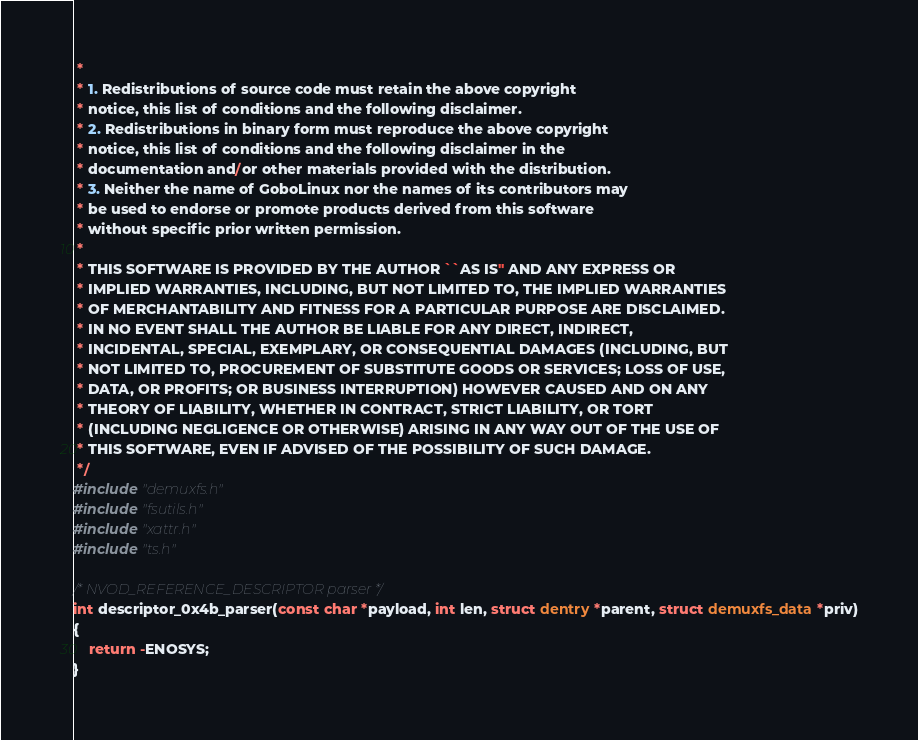<code> <loc_0><loc_0><loc_500><loc_500><_C_> * 
 * 1. Redistributions of source code must retain the above copyright
 * notice, this list of conditions and the following disclaimer.
 * 2. Redistributions in binary form must reproduce the above copyright
 * notice, this list of conditions and the following disclaimer in the
 * documentation and/or other materials provided with the distribution.
 * 3. Neither the name of GoboLinux nor the names of its contributors may
 * be used to endorse or promote products derived from this software
 * without specific prior written permission.
 * 
 * THIS SOFTWARE IS PROVIDED BY THE AUTHOR ``AS IS'' AND ANY EXPRESS OR
 * IMPLIED WARRANTIES, INCLUDING, BUT NOT LIMITED TO, THE IMPLIED WARRANTIES
 * OF MERCHANTABILITY AND FITNESS FOR A PARTICULAR PURPOSE ARE DISCLAIMED.
 * IN NO EVENT SHALL THE AUTHOR BE LIABLE FOR ANY DIRECT, INDIRECT,
 * INCIDENTAL, SPECIAL, EXEMPLARY, OR CONSEQUENTIAL DAMAGES (INCLUDING, BUT
 * NOT LIMITED TO, PROCUREMENT OF SUBSTITUTE GOODS OR SERVICES; LOSS OF USE,
 * DATA, OR PROFITS; OR BUSINESS INTERRUPTION) HOWEVER CAUSED AND ON ANY
 * THEORY OF LIABILITY, WHETHER IN CONTRACT, STRICT LIABILITY, OR TORT
 * (INCLUDING NEGLIGENCE OR OTHERWISE) ARISING IN ANY WAY OUT OF THE USE OF
 * THIS SOFTWARE, EVEN IF ADVISED OF THE POSSIBILITY OF SUCH DAMAGE.
 */
#include "demuxfs.h"
#include "fsutils.h"
#include "xattr.h"
#include "ts.h"

/* NVOD_REFERENCE_DESCRIPTOR parser */
int descriptor_0x4b_parser(const char *payload, int len, struct dentry *parent, struct demuxfs_data *priv)
{
    return -ENOSYS;
}

</code> 